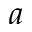<formula> <loc_0><loc_0><loc_500><loc_500>a</formula> 